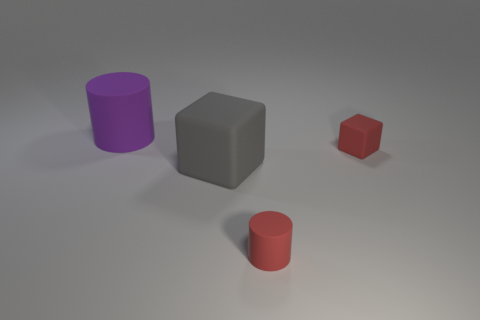Add 2 big blocks. How many objects exist? 6 Add 4 large cylinders. How many large cylinders exist? 5 Subtract 0 yellow spheres. How many objects are left? 4 Subtract all big cubes. Subtract all tiny matte cylinders. How many objects are left? 2 Add 2 tiny red cylinders. How many tiny red cylinders are left? 3 